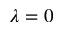Convert formula to latex. <formula><loc_0><loc_0><loc_500><loc_500>\lambda = 0</formula> 